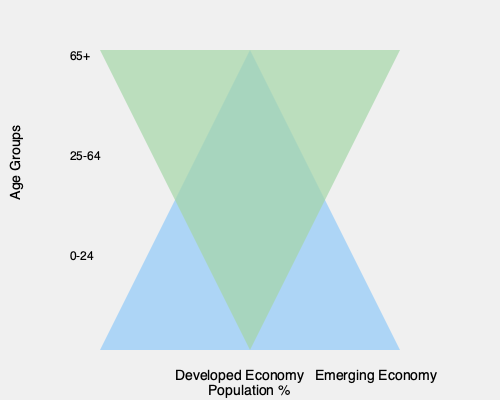As an entrepreneur looking at emerging economies for innovation opportunities, what key demographic difference does this population pyramid comparison reveal, and how might it influence your business strategy? To answer this question, let's analyze the population pyramids step-by-step:

1. Shape comparison:
   - Developed Economy: Narrow base, wide middle, and relatively wide top
   - Emerging Economy: Wide base, narrowing towards the top

2. Age distribution interpretation:
   - Developed Economy:
     a. Smaller young population (0-24)
     b. Large working-age population (25-64)
     c. Significant elderly population (65+)
   - Emerging Economy:
     a. Large young population (0-24)
     b. Smaller but growing working-age population (25-64)
     c. Small elderly population (65+)

3. Key demographic difference:
   The emerging economy has a much larger young population compared to the developed economy.

4. Business strategy implications:
   a. Large young customer base: Potential for products and services targeting youth and young adults
   b. Growing workforce: Opportunities for job creation and skill development
   c. Digital natives: Higher likelihood of tech-savvy consumers and workers
   d. Education needs: Potential for educational products and services
   e. Future economic growth: As the young population enters the workforce, there's potential for increased consumer spending and economic expansion

5. Innovation opportunities:
   a. Mobile-first solutions: Develop products and services optimized for mobile devices
   b. Ed-tech: Create innovative educational platforms and tools
   c. Fintech: Develop financial services for the unbanked or underbanked young population
   d. E-commerce: Build platforms catering to the needs of young consumers
   e. Workforce development: Create solutions for skill-building and job matching

As an entrepreneur, this demographic difference suggests focusing on youth-oriented, scalable, and technology-driven solutions that can grow with the emerging economy's young population as they enter the workforce and increase their economic power.
Answer: Larger young population in emerging economies; focus on youth-oriented, scalable, tech-driven solutions. 